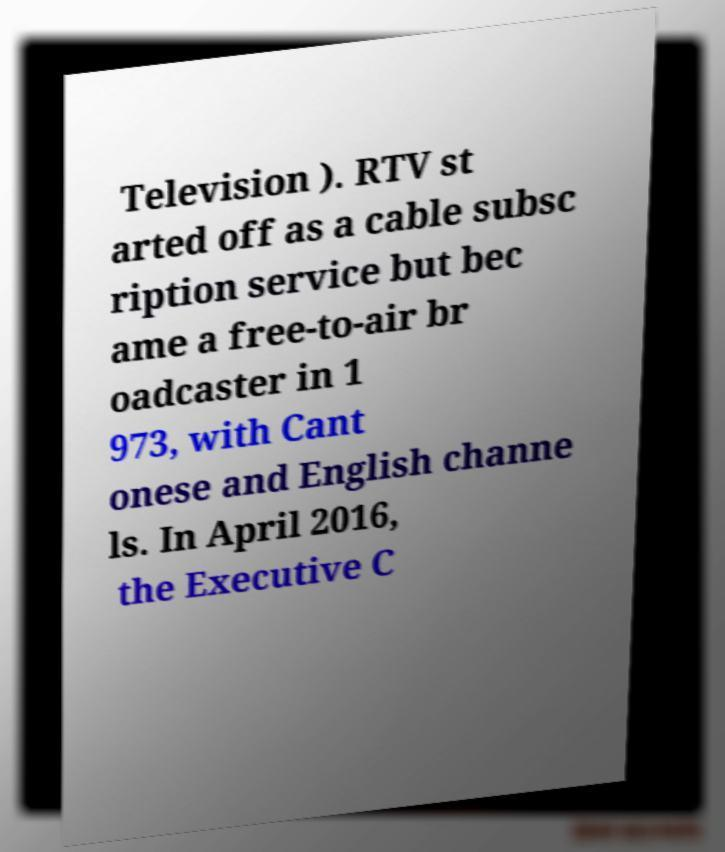I need the written content from this picture converted into text. Can you do that? Television ). RTV st arted off as a cable subsc ription service but bec ame a free-to-air br oadcaster in 1 973, with Cant onese and English channe ls. In April 2016, the Executive C 